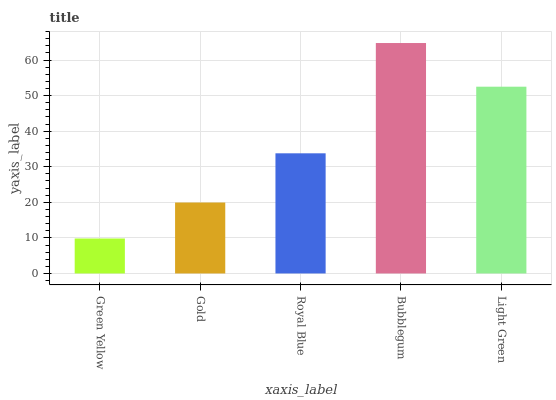Is Green Yellow the minimum?
Answer yes or no. Yes. Is Bubblegum the maximum?
Answer yes or no. Yes. Is Gold the minimum?
Answer yes or no. No. Is Gold the maximum?
Answer yes or no. No. Is Gold greater than Green Yellow?
Answer yes or no. Yes. Is Green Yellow less than Gold?
Answer yes or no. Yes. Is Green Yellow greater than Gold?
Answer yes or no. No. Is Gold less than Green Yellow?
Answer yes or no. No. Is Royal Blue the high median?
Answer yes or no. Yes. Is Royal Blue the low median?
Answer yes or no. Yes. Is Green Yellow the high median?
Answer yes or no. No. Is Green Yellow the low median?
Answer yes or no. No. 